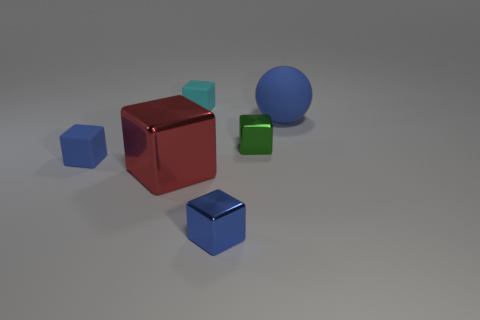Subtract all green blocks. How many blocks are left? 4 Subtract all large cubes. How many cubes are left? 4 Subtract all purple blocks. Subtract all cyan balls. How many blocks are left? 5 Add 4 big blue things. How many objects exist? 10 Subtract all blocks. How many objects are left? 1 Add 6 blue matte things. How many blue matte things are left? 8 Add 5 cyan things. How many cyan things exist? 6 Subtract 0 yellow cubes. How many objects are left? 6 Subtract all small objects. Subtract all matte spheres. How many objects are left? 1 